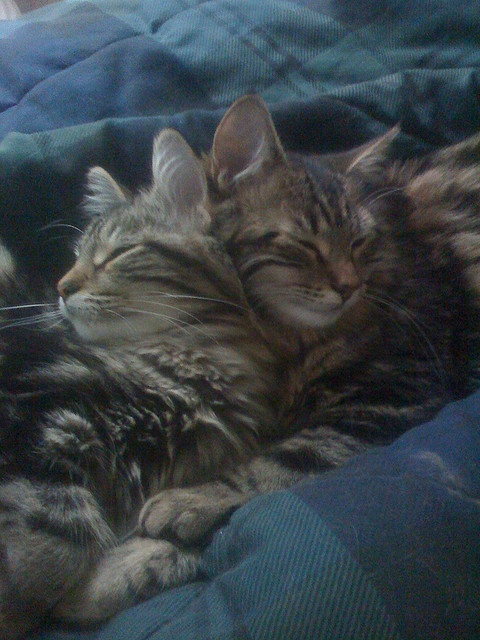Describe the objects in this image and their specific colors. I can see bed in darkgray, blue, black, and navy tones, cat in darkgray, black, and gray tones, and cat in darkgray, black, and gray tones in this image. 